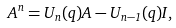<formula> <loc_0><loc_0><loc_500><loc_500>A ^ { n } = U _ { n } ( q ) A - U _ { n - 1 } ( q ) I ,</formula> 